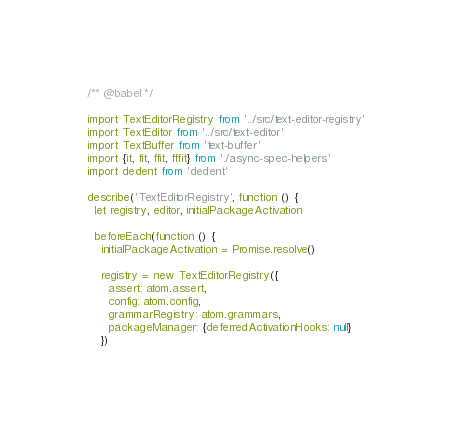Convert code to text. <code><loc_0><loc_0><loc_500><loc_500><_JavaScript_>/** @babel */

import TextEditorRegistry from '../src/text-editor-registry'
import TextEditor from '../src/text-editor'
import TextBuffer from 'text-buffer'
import {it, fit, ffit, fffit} from './async-spec-helpers'
import dedent from 'dedent'

describe('TextEditorRegistry', function () {
  let registry, editor, initialPackageActivation

  beforeEach(function () {
    initialPackageActivation = Promise.resolve()

    registry = new TextEditorRegistry({
      assert: atom.assert,
      config: atom.config,
      grammarRegistry: atom.grammars,
      packageManager: {deferredActivationHooks: null}
    })
</code> 